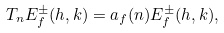Convert formula to latex. <formula><loc_0><loc_0><loc_500><loc_500>T _ { n } E _ { f } ^ { \pm } ( h , k ) = a _ { f } ( n ) E _ { f } ^ { \pm } ( h , k ) ,</formula> 